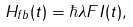<formula> <loc_0><loc_0><loc_500><loc_500>H _ { f b } ( t ) = \hbar { \lambda } F I ( t ) ,</formula> 